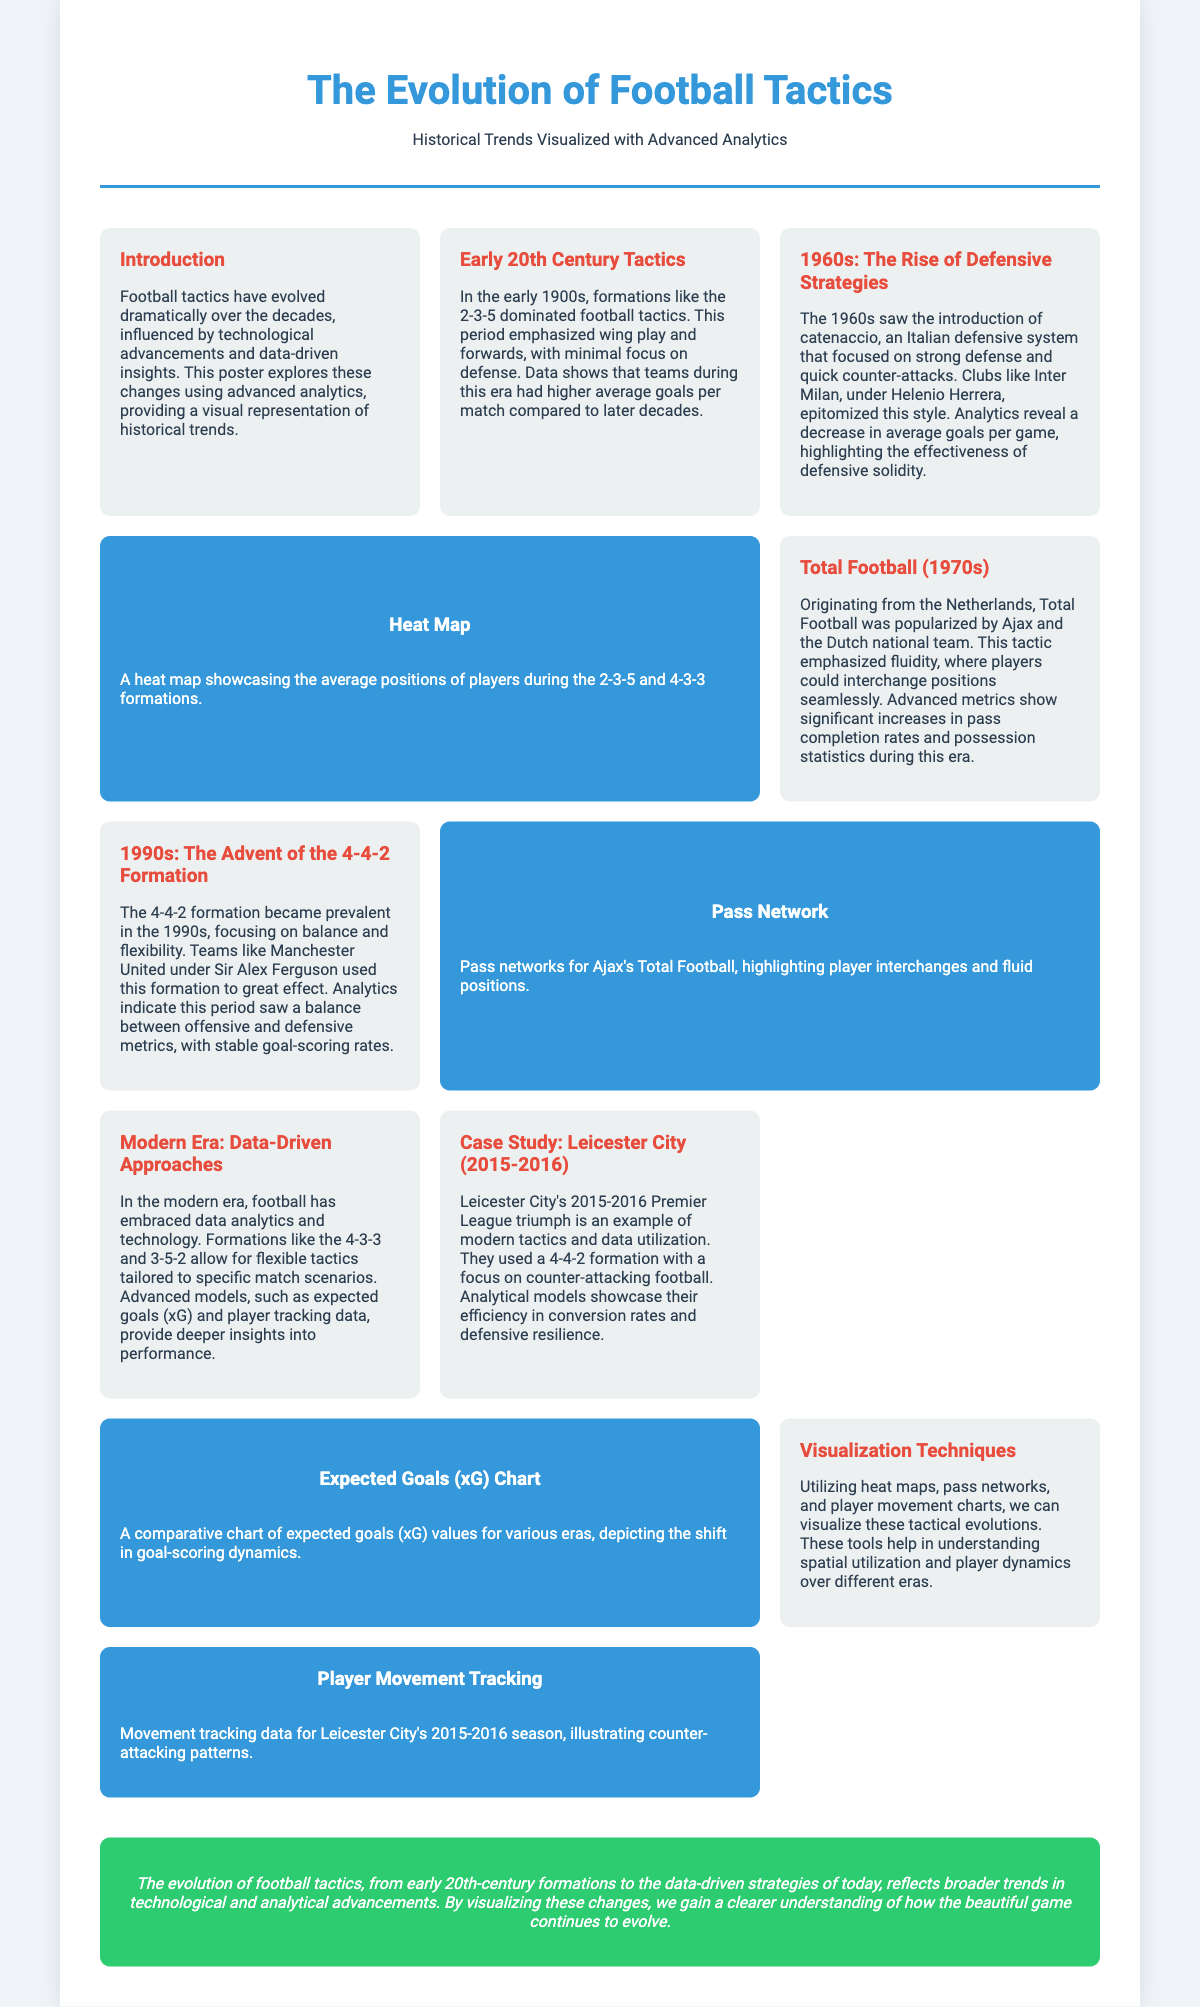What is the dominant formation in the early 20th century? The document states that formations like the 2-3-5 dominated football tactics in the early 1900s.
Answer: 2-3-5 What defensive strategy was introduced in the 1960s? The document mentions catenaccio as the defensive strategy introduced during this time.
Answer: catenaccio Which team epitomized Total Football in the 1970s? Ajax and the Dutch national team are highlighted as the teams that popularized Total Football.
Answer: Ajax What is the main tactical focus of Leicester City's 2015-2016 Premier League triumph? The document indicates that Leicester City's focus was on counter-attacking football with a 4-4-2 formation.
Answer: counter-attacking football What visualization technique is used to show player positions? The document mentions heat maps as a technique to visualize player positions.
Answer: heat maps How did average goals per game change in the 1960s? The document reveals a decrease in average goals per game during the 1960s due to the focus on defense.
Answer: decrease What is a significant metric that shows football performance in the modern era? Expected goals (xG) is highlighted as a significant metric in understanding football performance today.
Answer: expected goals (xG) Which era saw a balance between offensive and defensive metrics? The 1990s, with the prevalence of the 4-4-2 formation, is identified as a period of balanced metrics.
Answer: 1990s 